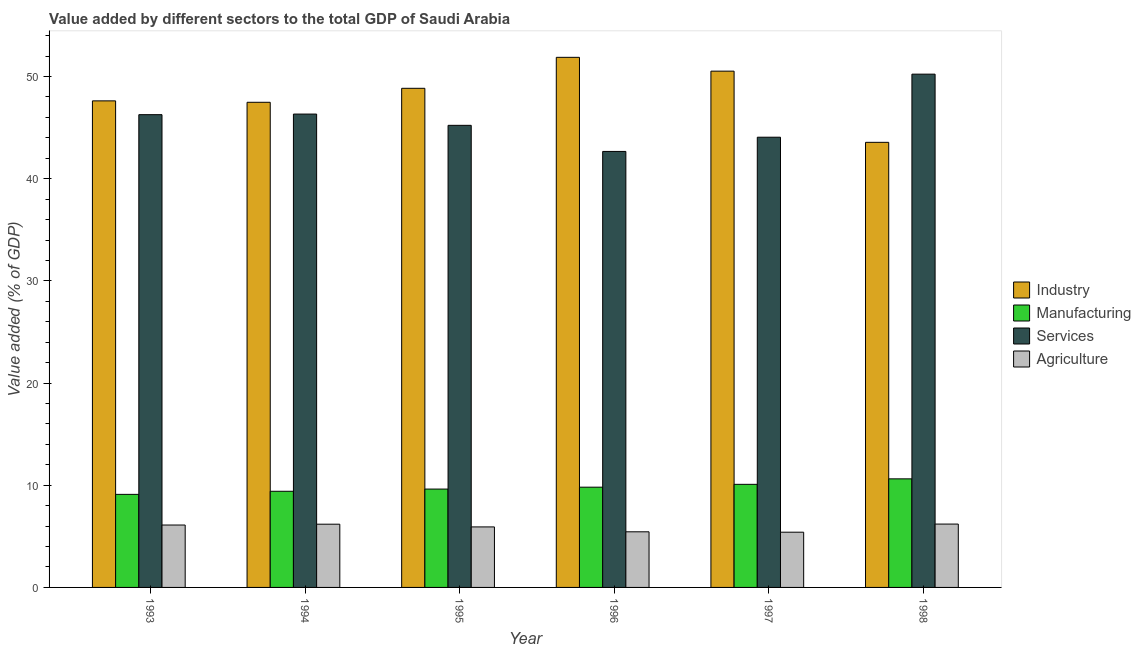How many different coloured bars are there?
Keep it short and to the point. 4. How many groups of bars are there?
Your answer should be very brief. 6. Are the number of bars per tick equal to the number of legend labels?
Offer a terse response. Yes. What is the value added by manufacturing sector in 1993?
Ensure brevity in your answer.  9.11. Across all years, what is the maximum value added by industrial sector?
Offer a very short reply. 51.88. Across all years, what is the minimum value added by manufacturing sector?
Your answer should be very brief. 9.11. In which year was the value added by services sector minimum?
Ensure brevity in your answer.  1996. What is the total value added by industrial sector in the graph?
Make the answer very short. 289.93. What is the difference between the value added by manufacturing sector in 1994 and that in 1995?
Give a very brief answer. -0.22. What is the difference between the value added by manufacturing sector in 1995 and the value added by industrial sector in 1996?
Keep it short and to the point. -0.19. What is the average value added by industrial sector per year?
Offer a very short reply. 48.32. What is the ratio of the value added by manufacturing sector in 1996 to that in 1997?
Offer a very short reply. 0.97. Is the value added by manufacturing sector in 1993 less than that in 1998?
Make the answer very short. Yes. Is the difference between the value added by agricultural sector in 1994 and 1997 greater than the difference between the value added by services sector in 1994 and 1997?
Your answer should be very brief. No. What is the difference between the highest and the second highest value added by agricultural sector?
Your answer should be compact. 0.01. What is the difference between the highest and the lowest value added by industrial sector?
Your answer should be very brief. 8.32. In how many years, is the value added by manufacturing sector greater than the average value added by manufacturing sector taken over all years?
Provide a short and direct response. 3. Is the sum of the value added by industrial sector in 1997 and 1998 greater than the maximum value added by manufacturing sector across all years?
Make the answer very short. Yes. Is it the case that in every year, the sum of the value added by industrial sector and value added by agricultural sector is greater than the sum of value added by services sector and value added by manufacturing sector?
Your response must be concise. Yes. What does the 4th bar from the left in 1994 represents?
Make the answer very short. Agriculture. What does the 3rd bar from the right in 1995 represents?
Provide a succinct answer. Manufacturing. Is it the case that in every year, the sum of the value added by industrial sector and value added by manufacturing sector is greater than the value added by services sector?
Offer a very short reply. Yes. How many bars are there?
Offer a very short reply. 24. How many years are there in the graph?
Ensure brevity in your answer.  6. What is the difference between two consecutive major ticks on the Y-axis?
Your answer should be very brief. 10. Are the values on the major ticks of Y-axis written in scientific E-notation?
Provide a succinct answer. No. How many legend labels are there?
Ensure brevity in your answer.  4. What is the title of the graph?
Your response must be concise. Value added by different sectors to the total GDP of Saudi Arabia. Does "Offering training" appear as one of the legend labels in the graph?
Offer a very short reply. No. What is the label or title of the X-axis?
Provide a succinct answer. Year. What is the label or title of the Y-axis?
Keep it short and to the point. Value added (% of GDP). What is the Value added (% of GDP) in Industry in 1993?
Make the answer very short. 47.62. What is the Value added (% of GDP) of Manufacturing in 1993?
Make the answer very short. 9.11. What is the Value added (% of GDP) in Services in 1993?
Provide a succinct answer. 46.27. What is the Value added (% of GDP) in Agriculture in 1993?
Give a very brief answer. 6.11. What is the Value added (% of GDP) in Industry in 1994?
Provide a short and direct response. 47.48. What is the Value added (% of GDP) in Manufacturing in 1994?
Provide a short and direct response. 9.41. What is the Value added (% of GDP) of Services in 1994?
Offer a very short reply. 46.33. What is the Value added (% of GDP) in Agriculture in 1994?
Your response must be concise. 6.19. What is the Value added (% of GDP) in Industry in 1995?
Your response must be concise. 48.85. What is the Value added (% of GDP) in Manufacturing in 1995?
Provide a succinct answer. 9.63. What is the Value added (% of GDP) in Services in 1995?
Your response must be concise. 45.23. What is the Value added (% of GDP) of Agriculture in 1995?
Ensure brevity in your answer.  5.92. What is the Value added (% of GDP) of Industry in 1996?
Provide a short and direct response. 51.88. What is the Value added (% of GDP) in Manufacturing in 1996?
Provide a succinct answer. 9.81. What is the Value added (% of GDP) of Services in 1996?
Your response must be concise. 42.67. What is the Value added (% of GDP) of Agriculture in 1996?
Ensure brevity in your answer.  5.44. What is the Value added (% of GDP) in Industry in 1997?
Offer a very short reply. 50.53. What is the Value added (% of GDP) in Manufacturing in 1997?
Provide a succinct answer. 10.09. What is the Value added (% of GDP) in Services in 1997?
Keep it short and to the point. 44.06. What is the Value added (% of GDP) of Agriculture in 1997?
Provide a short and direct response. 5.41. What is the Value added (% of GDP) in Industry in 1998?
Make the answer very short. 43.56. What is the Value added (% of GDP) of Manufacturing in 1998?
Keep it short and to the point. 10.63. What is the Value added (% of GDP) in Services in 1998?
Make the answer very short. 50.24. What is the Value added (% of GDP) in Agriculture in 1998?
Keep it short and to the point. 6.2. Across all years, what is the maximum Value added (% of GDP) in Industry?
Provide a short and direct response. 51.88. Across all years, what is the maximum Value added (% of GDP) of Manufacturing?
Make the answer very short. 10.63. Across all years, what is the maximum Value added (% of GDP) in Services?
Give a very brief answer. 50.24. Across all years, what is the maximum Value added (% of GDP) of Agriculture?
Your response must be concise. 6.2. Across all years, what is the minimum Value added (% of GDP) of Industry?
Give a very brief answer. 43.56. Across all years, what is the minimum Value added (% of GDP) of Manufacturing?
Your answer should be very brief. 9.11. Across all years, what is the minimum Value added (% of GDP) of Services?
Your answer should be very brief. 42.67. Across all years, what is the minimum Value added (% of GDP) in Agriculture?
Your response must be concise. 5.41. What is the total Value added (% of GDP) of Industry in the graph?
Your answer should be compact. 289.93. What is the total Value added (% of GDP) in Manufacturing in the graph?
Ensure brevity in your answer.  58.68. What is the total Value added (% of GDP) in Services in the graph?
Your response must be concise. 274.8. What is the total Value added (% of GDP) of Agriculture in the graph?
Your answer should be very brief. 35.27. What is the difference between the Value added (% of GDP) in Industry in 1993 and that in 1994?
Your response must be concise. 0.14. What is the difference between the Value added (% of GDP) of Manufacturing in 1993 and that in 1994?
Your answer should be compact. -0.3. What is the difference between the Value added (% of GDP) in Services in 1993 and that in 1994?
Your answer should be compact. -0.06. What is the difference between the Value added (% of GDP) in Agriculture in 1993 and that in 1994?
Provide a short and direct response. -0.08. What is the difference between the Value added (% of GDP) of Industry in 1993 and that in 1995?
Offer a terse response. -1.23. What is the difference between the Value added (% of GDP) of Manufacturing in 1993 and that in 1995?
Give a very brief answer. -0.52. What is the difference between the Value added (% of GDP) of Services in 1993 and that in 1995?
Your response must be concise. 1.04. What is the difference between the Value added (% of GDP) of Agriculture in 1993 and that in 1995?
Ensure brevity in your answer.  0.18. What is the difference between the Value added (% of GDP) in Industry in 1993 and that in 1996?
Give a very brief answer. -4.26. What is the difference between the Value added (% of GDP) of Manufacturing in 1993 and that in 1996?
Provide a short and direct response. -0.7. What is the difference between the Value added (% of GDP) in Services in 1993 and that in 1996?
Your answer should be compact. 3.6. What is the difference between the Value added (% of GDP) in Agriculture in 1993 and that in 1996?
Your answer should be very brief. 0.66. What is the difference between the Value added (% of GDP) in Industry in 1993 and that in 1997?
Provide a short and direct response. -2.91. What is the difference between the Value added (% of GDP) of Manufacturing in 1993 and that in 1997?
Offer a terse response. -0.98. What is the difference between the Value added (% of GDP) in Services in 1993 and that in 1997?
Make the answer very short. 2.21. What is the difference between the Value added (% of GDP) in Agriculture in 1993 and that in 1997?
Your answer should be very brief. 0.7. What is the difference between the Value added (% of GDP) in Industry in 1993 and that in 1998?
Your response must be concise. 4.06. What is the difference between the Value added (% of GDP) of Manufacturing in 1993 and that in 1998?
Provide a short and direct response. -1.52. What is the difference between the Value added (% of GDP) in Services in 1993 and that in 1998?
Provide a succinct answer. -3.96. What is the difference between the Value added (% of GDP) of Agriculture in 1993 and that in 1998?
Keep it short and to the point. -0.09. What is the difference between the Value added (% of GDP) in Industry in 1994 and that in 1995?
Keep it short and to the point. -1.37. What is the difference between the Value added (% of GDP) in Manufacturing in 1994 and that in 1995?
Keep it short and to the point. -0.22. What is the difference between the Value added (% of GDP) of Services in 1994 and that in 1995?
Give a very brief answer. 1.1. What is the difference between the Value added (% of GDP) in Agriculture in 1994 and that in 1995?
Your answer should be compact. 0.27. What is the difference between the Value added (% of GDP) in Industry in 1994 and that in 1996?
Provide a succinct answer. -4.4. What is the difference between the Value added (% of GDP) in Manufacturing in 1994 and that in 1996?
Offer a terse response. -0.4. What is the difference between the Value added (% of GDP) in Services in 1994 and that in 1996?
Provide a succinct answer. 3.66. What is the difference between the Value added (% of GDP) of Agriculture in 1994 and that in 1996?
Provide a short and direct response. 0.74. What is the difference between the Value added (% of GDP) of Industry in 1994 and that in 1997?
Provide a short and direct response. -3.05. What is the difference between the Value added (% of GDP) in Manufacturing in 1994 and that in 1997?
Provide a short and direct response. -0.68. What is the difference between the Value added (% of GDP) of Services in 1994 and that in 1997?
Ensure brevity in your answer.  2.26. What is the difference between the Value added (% of GDP) of Agriculture in 1994 and that in 1997?
Your answer should be compact. 0.78. What is the difference between the Value added (% of GDP) in Industry in 1994 and that in 1998?
Make the answer very short. 3.92. What is the difference between the Value added (% of GDP) of Manufacturing in 1994 and that in 1998?
Ensure brevity in your answer.  -1.22. What is the difference between the Value added (% of GDP) of Services in 1994 and that in 1998?
Keep it short and to the point. -3.91. What is the difference between the Value added (% of GDP) in Agriculture in 1994 and that in 1998?
Your answer should be very brief. -0.01. What is the difference between the Value added (% of GDP) of Industry in 1995 and that in 1996?
Ensure brevity in your answer.  -3.03. What is the difference between the Value added (% of GDP) of Manufacturing in 1995 and that in 1996?
Provide a succinct answer. -0.19. What is the difference between the Value added (% of GDP) of Services in 1995 and that in 1996?
Provide a succinct answer. 2.55. What is the difference between the Value added (% of GDP) of Agriculture in 1995 and that in 1996?
Provide a short and direct response. 0.48. What is the difference between the Value added (% of GDP) of Industry in 1995 and that in 1997?
Your answer should be compact. -1.68. What is the difference between the Value added (% of GDP) of Manufacturing in 1995 and that in 1997?
Provide a short and direct response. -0.46. What is the difference between the Value added (% of GDP) of Services in 1995 and that in 1997?
Give a very brief answer. 1.16. What is the difference between the Value added (% of GDP) of Agriculture in 1995 and that in 1997?
Provide a short and direct response. 0.52. What is the difference between the Value added (% of GDP) of Industry in 1995 and that in 1998?
Provide a succinct answer. 5.29. What is the difference between the Value added (% of GDP) of Manufacturing in 1995 and that in 1998?
Make the answer very short. -1. What is the difference between the Value added (% of GDP) in Services in 1995 and that in 1998?
Offer a very short reply. -5.01. What is the difference between the Value added (% of GDP) of Agriculture in 1995 and that in 1998?
Offer a terse response. -0.28. What is the difference between the Value added (% of GDP) of Industry in 1996 and that in 1997?
Provide a short and direct response. 1.35. What is the difference between the Value added (% of GDP) of Manufacturing in 1996 and that in 1997?
Provide a succinct answer. -0.28. What is the difference between the Value added (% of GDP) of Services in 1996 and that in 1997?
Keep it short and to the point. -1.39. What is the difference between the Value added (% of GDP) of Agriculture in 1996 and that in 1997?
Your answer should be compact. 0.04. What is the difference between the Value added (% of GDP) of Industry in 1996 and that in 1998?
Offer a terse response. 8.32. What is the difference between the Value added (% of GDP) in Manufacturing in 1996 and that in 1998?
Offer a terse response. -0.82. What is the difference between the Value added (% of GDP) of Services in 1996 and that in 1998?
Keep it short and to the point. -7.56. What is the difference between the Value added (% of GDP) in Agriculture in 1996 and that in 1998?
Offer a terse response. -0.76. What is the difference between the Value added (% of GDP) of Industry in 1997 and that in 1998?
Your response must be concise. 6.97. What is the difference between the Value added (% of GDP) in Manufacturing in 1997 and that in 1998?
Give a very brief answer. -0.54. What is the difference between the Value added (% of GDP) of Services in 1997 and that in 1998?
Keep it short and to the point. -6.17. What is the difference between the Value added (% of GDP) in Agriculture in 1997 and that in 1998?
Provide a short and direct response. -0.8. What is the difference between the Value added (% of GDP) of Industry in 1993 and the Value added (% of GDP) of Manufacturing in 1994?
Your answer should be very brief. 38.21. What is the difference between the Value added (% of GDP) of Industry in 1993 and the Value added (% of GDP) of Services in 1994?
Provide a short and direct response. 1.29. What is the difference between the Value added (% of GDP) in Industry in 1993 and the Value added (% of GDP) in Agriculture in 1994?
Make the answer very short. 41.43. What is the difference between the Value added (% of GDP) of Manufacturing in 1993 and the Value added (% of GDP) of Services in 1994?
Your response must be concise. -37.22. What is the difference between the Value added (% of GDP) of Manufacturing in 1993 and the Value added (% of GDP) of Agriculture in 1994?
Your answer should be compact. 2.92. What is the difference between the Value added (% of GDP) in Services in 1993 and the Value added (% of GDP) in Agriculture in 1994?
Offer a very short reply. 40.08. What is the difference between the Value added (% of GDP) of Industry in 1993 and the Value added (% of GDP) of Manufacturing in 1995?
Your response must be concise. 37.99. What is the difference between the Value added (% of GDP) in Industry in 1993 and the Value added (% of GDP) in Services in 1995?
Offer a terse response. 2.4. What is the difference between the Value added (% of GDP) in Industry in 1993 and the Value added (% of GDP) in Agriculture in 1995?
Your answer should be compact. 41.7. What is the difference between the Value added (% of GDP) in Manufacturing in 1993 and the Value added (% of GDP) in Services in 1995?
Make the answer very short. -36.12. What is the difference between the Value added (% of GDP) of Manufacturing in 1993 and the Value added (% of GDP) of Agriculture in 1995?
Your answer should be very brief. 3.18. What is the difference between the Value added (% of GDP) of Services in 1993 and the Value added (% of GDP) of Agriculture in 1995?
Your response must be concise. 40.35. What is the difference between the Value added (% of GDP) in Industry in 1993 and the Value added (% of GDP) in Manufacturing in 1996?
Make the answer very short. 37.81. What is the difference between the Value added (% of GDP) in Industry in 1993 and the Value added (% of GDP) in Services in 1996?
Ensure brevity in your answer.  4.95. What is the difference between the Value added (% of GDP) of Industry in 1993 and the Value added (% of GDP) of Agriculture in 1996?
Your answer should be very brief. 42.18. What is the difference between the Value added (% of GDP) of Manufacturing in 1993 and the Value added (% of GDP) of Services in 1996?
Your answer should be compact. -33.57. What is the difference between the Value added (% of GDP) in Manufacturing in 1993 and the Value added (% of GDP) in Agriculture in 1996?
Make the answer very short. 3.66. What is the difference between the Value added (% of GDP) of Services in 1993 and the Value added (% of GDP) of Agriculture in 1996?
Offer a terse response. 40.83. What is the difference between the Value added (% of GDP) of Industry in 1993 and the Value added (% of GDP) of Manufacturing in 1997?
Keep it short and to the point. 37.53. What is the difference between the Value added (% of GDP) in Industry in 1993 and the Value added (% of GDP) in Services in 1997?
Make the answer very short. 3.56. What is the difference between the Value added (% of GDP) of Industry in 1993 and the Value added (% of GDP) of Agriculture in 1997?
Ensure brevity in your answer.  42.22. What is the difference between the Value added (% of GDP) of Manufacturing in 1993 and the Value added (% of GDP) of Services in 1997?
Keep it short and to the point. -34.96. What is the difference between the Value added (% of GDP) in Manufacturing in 1993 and the Value added (% of GDP) in Agriculture in 1997?
Provide a succinct answer. 3.7. What is the difference between the Value added (% of GDP) of Services in 1993 and the Value added (% of GDP) of Agriculture in 1997?
Your answer should be compact. 40.87. What is the difference between the Value added (% of GDP) of Industry in 1993 and the Value added (% of GDP) of Manufacturing in 1998?
Give a very brief answer. 36.99. What is the difference between the Value added (% of GDP) in Industry in 1993 and the Value added (% of GDP) in Services in 1998?
Ensure brevity in your answer.  -2.61. What is the difference between the Value added (% of GDP) in Industry in 1993 and the Value added (% of GDP) in Agriculture in 1998?
Your answer should be compact. 41.42. What is the difference between the Value added (% of GDP) in Manufacturing in 1993 and the Value added (% of GDP) in Services in 1998?
Ensure brevity in your answer.  -41.13. What is the difference between the Value added (% of GDP) in Manufacturing in 1993 and the Value added (% of GDP) in Agriculture in 1998?
Keep it short and to the point. 2.91. What is the difference between the Value added (% of GDP) of Services in 1993 and the Value added (% of GDP) of Agriculture in 1998?
Your answer should be compact. 40.07. What is the difference between the Value added (% of GDP) of Industry in 1994 and the Value added (% of GDP) of Manufacturing in 1995?
Your answer should be very brief. 37.86. What is the difference between the Value added (% of GDP) in Industry in 1994 and the Value added (% of GDP) in Services in 1995?
Provide a short and direct response. 2.26. What is the difference between the Value added (% of GDP) in Industry in 1994 and the Value added (% of GDP) in Agriculture in 1995?
Keep it short and to the point. 41.56. What is the difference between the Value added (% of GDP) of Manufacturing in 1994 and the Value added (% of GDP) of Services in 1995?
Provide a short and direct response. -35.82. What is the difference between the Value added (% of GDP) in Manufacturing in 1994 and the Value added (% of GDP) in Agriculture in 1995?
Offer a very short reply. 3.49. What is the difference between the Value added (% of GDP) of Services in 1994 and the Value added (% of GDP) of Agriculture in 1995?
Provide a short and direct response. 40.41. What is the difference between the Value added (% of GDP) of Industry in 1994 and the Value added (% of GDP) of Manufacturing in 1996?
Your answer should be very brief. 37.67. What is the difference between the Value added (% of GDP) of Industry in 1994 and the Value added (% of GDP) of Services in 1996?
Your answer should be very brief. 4.81. What is the difference between the Value added (% of GDP) in Industry in 1994 and the Value added (% of GDP) in Agriculture in 1996?
Keep it short and to the point. 42.04. What is the difference between the Value added (% of GDP) of Manufacturing in 1994 and the Value added (% of GDP) of Services in 1996?
Keep it short and to the point. -33.26. What is the difference between the Value added (% of GDP) of Manufacturing in 1994 and the Value added (% of GDP) of Agriculture in 1996?
Offer a very short reply. 3.97. What is the difference between the Value added (% of GDP) in Services in 1994 and the Value added (% of GDP) in Agriculture in 1996?
Your answer should be very brief. 40.88. What is the difference between the Value added (% of GDP) of Industry in 1994 and the Value added (% of GDP) of Manufacturing in 1997?
Ensure brevity in your answer.  37.39. What is the difference between the Value added (% of GDP) in Industry in 1994 and the Value added (% of GDP) in Services in 1997?
Offer a terse response. 3.42. What is the difference between the Value added (% of GDP) in Industry in 1994 and the Value added (% of GDP) in Agriculture in 1997?
Your answer should be compact. 42.08. What is the difference between the Value added (% of GDP) in Manufacturing in 1994 and the Value added (% of GDP) in Services in 1997?
Offer a very short reply. -34.65. What is the difference between the Value added (% of GDP) of Manufacturing in 1994 and the Value added (% of GDP) of Agriculture in 1997?
Provide a succinct answer. 4.01. What is the difference between the Value added (% of GDP) of Services in 1994 and the Value added (% of GDP) of Agriculture in 1997?
Offer a very short reply. 40.92. What is the difference between the Value added (% of GDP) in Industry in 1994 and the Value added (% of GDP) in Manufacturing in 1998?
Your response must be concise. 36.86. What is the difference between the Value added (% of GDP) in Industry in 1994 and the Value added (% of GDP) in Services in 1998?
Keep it short and to the point. -2.75. What is the difference between the Value added (% of GDP) of Industry in 1994 and the Value added (% of GDP) of Agriculture in 1998?
Your answer should be compact. 41.28. What is the difference between the Value added (% of GDP) in Manufacturing in 1994 and the Value added (% of GDP) in Services in 1998?
Your answer should be very brief. -40.82. What is the difference between the Value added (% of GDP) in Manufacturing in 1994 and the Value added (% of GDP) in Agriculture in 1998?
Keep it short and to the point. 3.21. What is the difference between the Value added (% of GDP) in Services in 1994 and the Value added (% of GDP) in Agriculture in 1998?
Make the answer very short. 40.13. What is the difference between the Value added (% of GDP) of Industry in 1995 and the Value added (% of GDP) of Manufacturing in 1996?
Offer a very short reply. 39.04. What is the difference between the Value added (% of GDP) of Industry in 1995 and the Value added (% of GDP) of Services in 1996?
Give a very brief answer. 6.18. What is the difference between the Value added (% of GDP) in Industry in 1995 and the Value added (% of GDP) in Agriculture in 1996?
Offer a very short reply. 43.41. What is the difference between the Value added (% of GDP) of Manufacturing in 1995 and the Value added (% of GDP) of Services in 1996?
Keep it short and to the point. -33.05. What is the difference between the Value added (% of GDP) in Manufacturing in 1995 and the Value added (% of GDP) in Agriculture in 1996?
Ensure brevity in your answer.  4.18. What is the difference between the Value added (% of GDP) of Services in 1995 and the Value added (% of GDP) of Agriculture in 1996?
Your response must be concise. 39.78. What is the difference between the Value added (% of GDP) in Industry in 1995 and the Value added (% of GDP) in Manufacturing in 1997?
Offer a terse response. 38.76. What is the difference between the Value added (% of GDP) in Industry in 1995 and the Value added (% of GDP) in Services in 1997?
Your response must be concise. 4.79. What is the difference between the Value added (% of GDP) of Industry in 1995 and the Value added (% of GDP) of Agriculture in 1997?
Provide a succinct answer. 43.45. What is the difference between the Value added (% of GDP) in Manufacturing in 1995 and the Value added (% of GDP) in Services in 1997?
Provide a short and direct response. -34.44. What is the difference between the Value added (% of GDP) of Manufacturing in 1995 and the Value added (% of GDP) of Agriculture in 1997?
Your answer should be very brief. 4.22. What is the difference between the Value added (% of GDP) of Services in 1995 and the Value added (% of GDP) of Agriculture in 1997?
Your answer should be compact. 39.82. What is the difference between the Value added (% of GDP) of Industry in 1995 and the Value added (% of GDP) of Manufacturing in 1998?
Your response must be concise. 38.22. What is the difference between the Value added (% of GDP) in Industry in 1995 and the Value added (% of GDP) in Services in 1998?
Provide a succinct answer. -1.39. What is the difference between the Value added (% of GDP) of Industry in 1995 and the Value added (% of GDP) of Agriculture in 1998?
Your answer should be compact. 42.65. What is the difference between the Value added (% of GDP) in Manufacturing in 1995 and the Value added (% of GDP) in Services in 1998?
Give a very brief answer. -40.61. What is the difference between the Value added (% of GDP) in Manufacturing in 1995 and the Value added (% of GDP) in Agriculture in 1998?
Ensure brevity in your answer.  3.43. What is the difference between the Value added (% of GDP) in Services in 1995 and the Value added (% of GDP) in Agriculture in 1998?
Make the answer very short. 39.02. What is the difference between the Value added (% of GDP) in Industry in 1996 and the Value added (% of GDP) in Manufacturing in 1997?
Offer a very short reply. 41.79. What is the difference between the Value added (% of GDP) in Industry in 1996 and the Value added (% of GDP) in Services in 1997?
Offer a terse response. 7.82. What is the difference between the Value added (% of GDP) in Industry in 1996 and the Value added (% of GDP) in Agriculture in 1997?
Ensure brevity in your answer.  46.48. What is the difference between the Value added (% of GDP) of Manufacturing in 1996 and the Value added (% of GDP) of Services in 1997?
Give a very brief answer. -34.25. What is the difference between the Value added (% of GDP) of Manufacturing in 1996 and the Value added (% of GDP) of Agriculture in 1997?
Make the answer very short. 4.41. What is the difference between the Value added (% of GDP) of Services in 1996 and the Value added (% of GDP) of Agriculture in 1997?
Offer a very short reply. 37.27. What is the difference between the Value added (% of GDP) in Industry in 1996 and the Value added (% of GDP) in Manufacturing in 1998?
Make the answer very short. 41.26. What is the difference between the Value added (% of GDP) in Industry in 1996 and the Value added (% of GDP) in Services in 1998?
Your response must be concise. 1.65. What is the difference between the Value added (% of GDP) of Industry in 1996 and the Value added (% of GDP) of Agriculture in 1998?
Your answer should be very brief. 45.68. What is the difference between the Value added (% of GDP) of Manufacturing in 1996 and the Value added (% of GDP) of Services in 1998?
Your response must be concise. -40.42. What is the difference between the Value added (% of GDP) in Manufacturing in 1996 and the Value added (% of GDP) in Agriculture in 1998?
Your response must be concise. 3.61. What is the difference between the Value added (% of GDP) in Services in 1996 and the Value added (% of GDP) in Agriculture in 1998?
Offer a very short reply. 36.47. What is the difference between the Value added (% of GDP) of Industry in 1997 and the Value added (% of GDP) of Manufacturing in 1998?
Your answer should be very brief. 39.9. What is the difference between the Value added (% of GDP) in Industry in 1997 and the Value added (% of GDP) in Services in 1998?
Keep it short and to the point. 0.29. What is the difference between the Value added (% of GDP) in Industry in 1997 and the Value added (% of GDP) in Agriculture in 1998?
Keep it short and to the point. 44.33. What is the difference between the Value added (% of GDP) in Manufacturing in 1997 and the Value added (% of GDP) in Services in 1998?
Your answer should be very brief. -40.15. What is the difference between the Value added (% of GDP) of Manufacturing in 1997 and the Value added (% of GDP) of Agriculture in 1998?
Give a very brief answer. 3.89. What is the difference between the Value added (% of GDP) in Services in 1997 and the Value added (% of GDP) in Agriculture in 1998?
Your answer should be compact. 37.86. What is the average Value added (% of GDP) of Industry per year?
Your response must be concise. 48.32. What is the average Value added (% of GDP) of Manufacturing per year?
Offer a very short reply. 9.78. What is the average Value added (% of GDP) of Services per year?
Provide a short and direct response. 45.8. What is the average Value added (% of GDP) in Agriculture per year?
Offer a very short reply. 5.88. In the year 1993, what is the difference between the Value added (% of GDP) in Industry and Value added (% of GDP) in Manufacturing?
Ensure brevity in your answer.  38.51. In the year 1993, what is the difference between the Value added (% of GDP) of Industry and Value added (% of GDP) of Services?
Your response must be concise. 1.35. In the year 1993, what is the difference between the Value added (% of GDP) in Industry and Value added (% of GDP) in Agriculture?
Make the answer very short. 41.51. In the year 1993, what is the difference between the Value added (% of GDP) of Manufacturing and Value added (% of GDP) of Services?
Provide a succinct answer. -37.16. In the year 1993, what is the difference between the Value added (% of GDP) in Manufacturing and Value added (% of GDP) in Agriculture?
Offer a terse response. 3. In the year 1993, what is the difference between the Value added (% of GDP) in Services and Value added (% of GDP) in Agriculture?
Give a very brief answer. 40.16. In the year 1994, what is the difference between the Value added (% of GDP) in Industry and Value added (% of GDP) in Manufacturing?
Make the answer very short. 38.07. In the year 1994, what is the difference between the Value added (% of GDP) in Industry and Value added (% of GDP) in Services?
Give a very brief answer. 1.15. In the year 1994, what is the difference between the Value added (% of GDP) in Industry and Value added (% of GDP) in Agriculture?
Give a very brief answer. 41.29. In the year 1994, what is the difference between the Value added (% of GDP) in Manufacturing and Value added (% of GDP) in Services?
Provide a short and direct response. -36.92. In the year 1994, what is the difference between the Value added (% of GDP) in Manufacturing and Value added (% of GDP) in Agriculture?
Offer a terse response. 3.22. In the year 1994, what is the difference between the Value added (% of GDP) of Services and Value added (% of GDP) of Agriculture?
Offer a terse response. 40.14. In the year 1995, what is the difference between the Value added (% of GDP) in Industry and Value added (% of GDP) in Manufacturing?
Your response must be concise. 39.22. In the year 1995, what is the difference between the Value added (% of GDP) of Industry and Value added (% of GDP) of Services?
Your response must be concise. 3.62. In the year 1995, what is the difference between the Value added (% of GDP) in Industry and Value added (% of GDP) in Agriculture?
Your answer should be very brief. 42.93. In the year 1995, what is the difference between the Value added (% of GDP) in Manufacturing and Value added (% of GDP) in Services?
Keep it short and to the point. -35.6. In the year 1995, what is the difference between the Value added (% of GDP) in Manufacturing and Value added (% of GDP) in Agriculture?
Make the answer very short. 3.7. In the year 1995, what is the difference between the Value added (% of GDP) of Services and Value added (% of GDP) of Agriculture?
Make the answer very short. 39.3. In the year 1996, what is the difference between the Value added (% of GDP) of Industry and Value added (% of GDP) of Manufacturing?
Your answer should be compact. 42.07. In the year 1996, what is the difference between the Value added (% of GDP) in Industry and Value added (% of GDP) in Services?
Your answer should be very brief. 9.21. In the year 1996, what is the difference between the Value added (% of GDP) in Industry and Value added (% of GDP) in Agriculture?
Your response must be concise. 46.44. In the year 1996, what is the difference between the Value added (% of GDP) in Manufacturing and Value added (% of GDP) in Services?
Provide a short and direct response. -32.86. In the year 1996, what is the difference between the Value added (% of GDP) of Manufacturing and Value added (% of GDP) of Agriculture?
Provide a short and direct response. 4.37. In the year 1996, what is the difference between the Value added (% of GDP) in Services and Value added (% of GDP) in Agriculture?
Your response must be concise. 37.23. In the year 1997, what is the difference between the Value added (% of GDP) of Industry and Value added (% of GDP) of Manufacturing?
Provide a succinct answer. 40.44. In the year 1997, what is the difference between the Value added (% of GDP) in Industry and Value added (% of GDP) in Services?
Make the answer very short. 6.46. In the year 1997, what is the difference between the Value added (% of GDP) of Industry and Value added (% of GDP) of Agriculture?
Give a very brief answer. 45.12. In the year 1997, what is the difference between the Value added (% of GDP) in Manufacturing and Value added (% of GDP) in Services?
Keep it short and to the point. -33.97. In the year 1997, what is the difference between the Value added (% of GDP) of Manufacturing and Value added (% of GDP) of Agriculture?
Your answer should be very brief. 4.69. In the year 1997, what is the difference between the Value added (% of GDP) in Services and Value added (% of GDP) in Agriculture?
Ensure brevity in your answer.  38.66. In the year 1998, what is the difference between the Value added (% of GDP) of Industry and Value added (% of GDP) of Manufacturing?
Your answer should be very brief. 32.94. In the year 1998, what is the difference between the Value added (% of GDP) of Industry and Value added (% of GDP) of Services?
Ensure brevity in your answer.  -6.67. In the year 1998, what is the difference between the Value added (% of GDP) of Industry and Value added (% of GDP) of Agriculture?
Offer a very short reply. 37.36. In the year 1998, what is the difference between the Value added (% of GDP) in Manufacturing and Value added (% of GDP) in Services?
Your answer should be compact. -39.61. In the year 1998, what is the difference between the Value added (% of GDP) of Manufacturing and Value added (% of GDP) of Agriculture?
Your response must be concise. 4.43. In the year 1998, what is the difference between the Value added (% of GDP) in Services and Value added (% of GDP) in Agriculture?
Provide a short and direct response. 44.03. What is the ratio of the Value added (% of GDP) of Industry in 1993 to that in 1994?
Provide a succinct answer. 1. What is the ratio of the Value added (% of GDP) of Manufacturing in 1993 to that in 1994?
Make the answer very short. 0.97. What is the ratio of the Value added (% of GDP) in Agriculture in 1993 to that in 1994?
Provide a succinct answer. 0.99. What is the ratio of the Value added (% of GDP) in Industry in 1993 to that in 1995?
Provide a succinct answer. 0.97. What is the ratio of the Value added (% of GDP) in Manufacturing in 1993 to that in 1995?
Give a very brief answer. 0.95. What is the ratio of the Value added (% of GDP) in Services in 1993 to that in 1995?
Give a very brief answer. 1.02. What is the ratio of the Value added (% of GDP) of Agriculture in 1993 to that in 1995?
Offer a terse response. 1.03. What is the ratio of the Value added (% of GDP) of Industry in 1993 to that in 1996?
Offer a very short reply. 0.92. What is the ratio of the Value added (% of GDP) in Manufacturing in 1993 to that in 1996?
Offer a very short reply. 0.93. What is the ratio of the Value added (% of GDP) of Services in 1993 to that in 1996?
Give a very brief answer. 1.08. What is the ratio of the Value added (% of GDP) of Agriculture in 1993 to that in 1996?
Provide a succinct answer. 1.12. What is the ratio of the Value added (% of GDP) in Industry in 1993 to that in 1997?
Provide a short and direct response. 0.94. What is the ratio of the Value added (% of GDP) in Manufacturing in 1993 to that in 1997?
Give a very brief answer. 0.9. What is the ratio of the Value added (% of GDP) in Services in 1993 to that in 1997?
Make the answer very short. 1.05. What is the ratio of the Value added (% of GDP) in Agriculture in 1993 to that in 1997?
Provide a succinct answer. 1.13. What is the ratio of the Value added (% of GDP) in Industry in 1993 to that in 1998?
Your answer should be compact. 1.09. What is the ratio of the Value added (% of GDP) in Manufacturing in 1993 to that in 1998?
Give a very brief answer. 0.86. What is the ratio of the Value added (% of GDP) of Services in 1993 to that in 1998?
Ensure brevity in your answer.  0.92. What is the ratio of the Value added (% of GDP) of Agriculture in 1993 to that in 1998?
Your answer should be very brief. 0.98. What is the ratio of the Value added (% of GDP) in Industry in 1994 to that in 1995?
Offer a very short reply. 0.97. What is the ratio of the Value added (% of GDP) in Manufacturing in 1994 to that in 1995?
Your answer should be compact. 0.98. What is the ratio of the Value added (% of GDP) of Services in 1994 to that in 1995?
Your answer should be very brief. 1.02. What is the ratio of the Value added (% of GDP) in Agriculture in 1994 to that in 1995?
Offer a very short reply. 1.04. What is the ratio of the Value added (% of GDP) in Industry in 1994 to that in 1996?
Provide a succinct answer. 0.92. What is the ratio of the Value added (% of GDP) of Manufacturing in 1994 to that in 1996?
Keep it short and to the point. 0.96. What is the ratio of the Value added (% of GDP) of Services in 1994 to that in 1996?
Provide a succinct answer. 1.09. What is the ratio of the Value added (% of GDP) in Agriculture in 1994 to that in 1996?
Your answer should be very brief. 1.14. What is the ratio of the Value added (% of GDP) of Industry in 1994 to that in 1997?
Make the answer very short. 0.94. What is the ratio of the Value added (% of GDP) of Manufacturing in 1994 to that in 1997?
Make the answer very short. 0.93. What is the ratio of the Value added (% of GDP) in Services in 1994 to that in 1997?
Give a very brief answer. 1.05. What is the ratio of the Value added (% of GDP) of Agriculture in 1994 to that in 1997?
Offer a terse response. 1.14. What is the ratio of the Value added (% of GDP) in Industry in 1994 to that in 1998?
Give a very brief answer. 1.09. What is the ratio of the Value added (% of GDP) in Manufacturing in 1994 to that in 1998?
Keep it short and to the point. 0.89. What is the ratio of the Value added (% of GDP) of Services in 1994 to that in 1998?
Keep it short and to the point. 0.92. What is the ratio of the Value added (% of GDP) in Agriculture in 1994 to that in 1998?
Offer a very short reply. 1. What is the ratio of the Value added (% of GDP) in Industry in 1995 to that in 1996?
Offer a very short reply. 0.94. What is the ratio of the Value added (% of GDP) in Manufacturing in 1995 to that in 1996?
Ensure brevity in your answer.  0.98. What is the ratio of the Value added (% of GDP) of Services in 1995 to that in 1996?
Keep it short and to the point. 1.06. What is the ratio of the Value added (% of GDP) in Agriculture in 1995 to that in 1996?
Your answer should be very brief. 1.09. What is the ratio of the Value added (% of GDP) of Industry in 1995 to that in 1997?
Offer a terse response. 0.97. What is the ratio of the Value added (% of GDP) of Manufacturing in 1995 to that in 1997?
Ensure brevity in your answer.  0.95. What is the ratio of the Value added (% of GDP) of Services in 1995 to that in 1997?
Make the answer very short. 1.03. What is the ratio of the Value added (% of GDP) of Agriculture in 1995 to that in 1997?
Your answer should be very brief. 1.1. What is the ratio of the Value added (% of GDP) of Industry in 1995 to that in 1998?
Provide a succinct answer. 1.12. What is the ratio of the Value added (% of GDP) of Manufacturing in 1995 to that in 1998?
Offer a terse response. 0.91. What is the ratio of the Value added (% of GDP) of Services in 1995 to that in 1998?
Your answer should be very brief. 0.9. What is the ratio of the Value added (% of GDP) in Agriculture in 1995 to that in 1998?
Make the answer very short. 0.95. What is the ratio of the Value added (% of GDP) of Industry in 1996 to that in 1997?
Provide a short and direct response. 1.03. What is the ratio of the Value added (% of GDP) in Manufacturing in 1996 to that in 1997?
Make the answer very short. 0.97. What is the ratio of the Value added (% of GDP) in Services in 1996 to that in 1997?
Ensure brevity in your answer.  0.97. What is the ratio of the Value added (% of GDP) of Agriculture in 1996 to that in 1997?
Your answer should be very brief. 1.01. What is the ratio of the Value added (% of GDP) of Industry in 1996 to that in 1998?
Keep it short and to the point. 1.19. What is the ratio of the Value added (% of GDP) in Manufacturing in 1996 to that in 1998?
Provide a succinct answer. 0.92. What is the ratio of the Value added (% of GDP) in Services in 1996 to that in 1998?
Offer a terse response. 0.85. What is the ratio of the Value added (% of GDP) of Agriculture in 1996 to that in 1998?
Offer a very short reply. 0.88. What is the ratio of the Value added (% of GDP) in Industry in 1997 to that in 1998?
Provide a succinct answer. 1.16. What is the ratio of the Value added (% of GDP) in Manufacturing in 1997 to that in 1998?
Make the answer very short. 0.95. What is the ratio of the Value added (% of GDP) of Services in 1997 to that in 1998?
Your answer should be very brief. 0.88. What is the ratio of the Value added (% of GDP) in Agriculture in 1997 to that in 1998?
Your answer should be compact. 0.87. What is the difference between the highest and the second highest Value added (% of GDP) in Industry?
Provide a short and direct response. 1.35. What is the difference between the highest and the second highest Value added (% of GDP) of Manufacturing?
Give a very brief answer. 0.54. What is the difference between the highest and the second highest Value added (% of GDP) in Services?
Keep it short and to the point. 3.91. What is the difference between the highest and the second highest Value added (% of GDP) in Agriculture?
Give a very brief answer. 0.01. What is the difference between the highest and the lowest Value added (% of GDP) in Industry?
Offer a very short reply. 8.32. What is the difference between the highest and the lowest Value added (% of GDP) of Manufacturing?
Provide a succinct answer. 1.52. What is the difference between the highest and the lowest Value added (% of GDP) in Services?
Offer a terse response. 7.56. What is the difference between the highest and the lowest Value added (% of GDP) in Agriculture?
Your response must be concise. 0.8. 